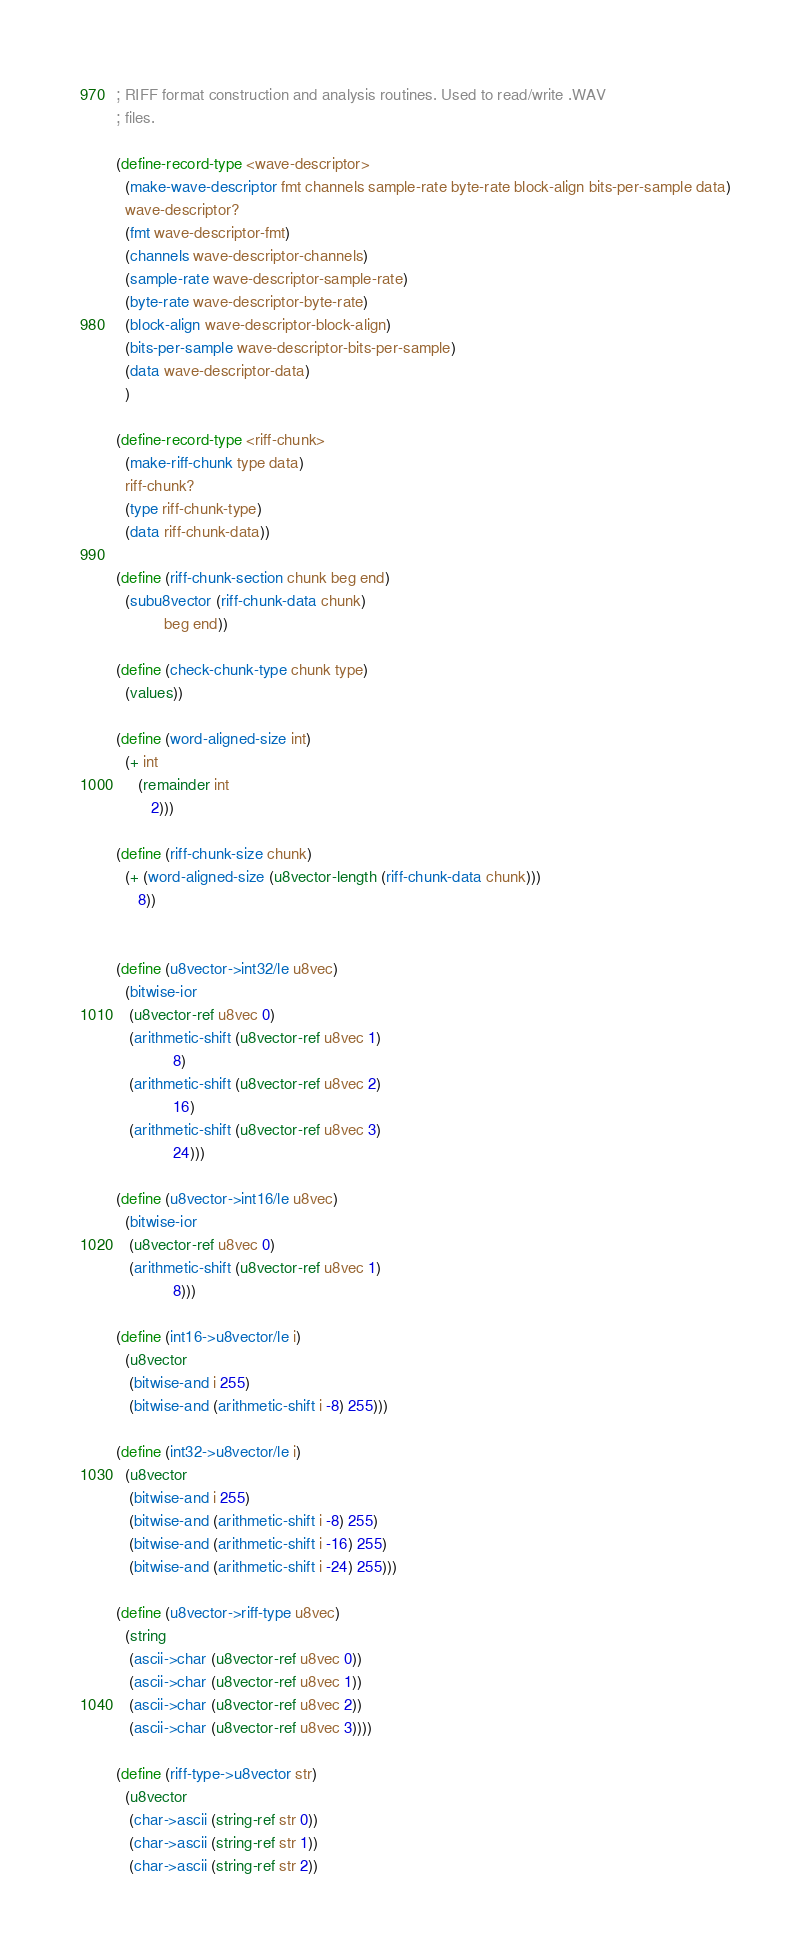<code> <loc_0><loc_0><loc_500><loc_500><_Scheme_>; RIFF format construction and analysis routines. Used to read/write .WAV
; files.

(define-record-type <wave-descriptor>
  (make-wave-descriptor fmt channels sample-rate byte-rate block-align bits-per-sample data)
  wave-descriptor?
  (fmt wave-descriptor-fmt)
  (channels wave-descriptor-channels)
  (sample-rate wave-descriptor-sample-rate)
  (byte-rate wave-descriptor-byte-rate)
  (block-align wave-descriptor-block-align)
  (bits-per-sample wave-descriptor-bits-per-sample)
  (data wave-descriptor-data)
  )

(define-record-type <riff-chunk>
  (make-riff-chunk type data)
  riff-chunk?
  (type riff-chunk-type)
  (data riff-chunk-data))

(define (riff-chunk-section chunk beg end)
  (subu8vector (riff-chunk-data chunk)
	       beg end))

(define (check-chunk-type chunk type)
  (values))

(define (word-aligned-size int)
  (+ int
     (remainder int
		2)))

(define (riff-chunk-size chunk)
  (+ (word-aligned-size (u8vector-length (riff-chunk-data chunk)))
     8))


(define (u8vector->int32/le u8vec)
  (bitwise-ior
   (u8vector-ref u8vec 0)
   (arithmetic-shift (u8vector-ref u8vec 1)
		     8)
   (arithmetic-shift (u8vector-ref u8vec 2)
		     16)
   (arithmetic-shift (u8vector-ref u8vec 3)
		     24)))

(define (u8vector->int16/le u8vec)
  (bitwise-ior
   (u8vector-ref u8vec 0)
   (arithmetic-shift (u8vector-ref u8vec 1)
		     8)))

(define (int16->u8vector/le i)
  (u8vector
   (bitwise-and i 255)
   (bitwise-and (arithmetic-shift i -8) 255)))

(define (int32->u8vector/le i)
  (u8vector
   (bitwise-and i 255)
   (bitwise-and (arithmetic-shift i -8) 255)
   (bitwise-and (arithmetic-shift i -16) 255)
   (bitwise-and (arithmetic-shift i -24) 255)))

(define (u8vector->riff-type u8vec)
  (string
   (ascii->char (u8vector-ref u8vec 0))
   (ascii->char (u8vector-ref u8vec 1))
   (ascii->char (u8vector-ref u8vec 2))
   (ascii->char (u8vector-ref u8vec 3))))

(define (riff-type->u8vector str)
  (u8vector
   (char->ascii (string-ref str 0))
   (char->ascii (string-ref str 1))
   (char->ascii (string-ref str 2))</code> 